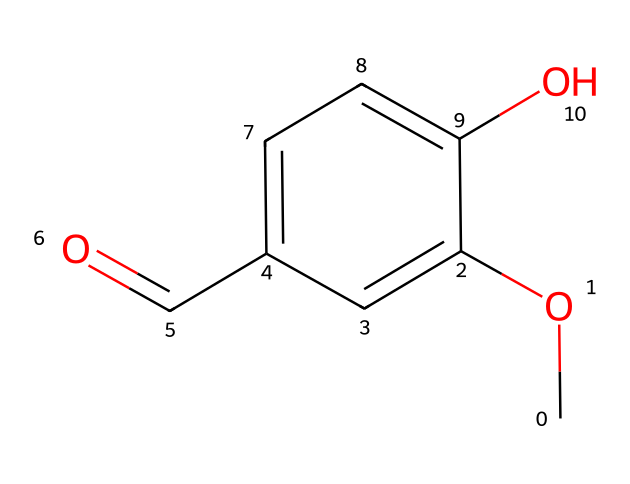What is the molecular formula of vanillin? The molecular formula can be derived from the SMILES representation by counting the atoms. In the representation, there is one carbonyl group (C=O), six carbons in the aromatic ring, two oxygen atoms, and six hydrogen atoms. Thus, the molecular formula is C8H8O3.
Answer: C8H8O3 How many carbon atoms are present in vanillin? By examining the SMILES representation, we can count the carbon atoms. There are a total of eight carbon atoms in the structure: one in the carbonyl group and the remaining seven in the aromatic ring.
Answer: 8 What functional groups are present in vanillin? From the SMILES structure, we can identify the functional groups. The key identifiable groups are an aldehyde (C=O) and a methoxy group (O-CH3) attached to the aromatic ring. Therefore, the functional groups present are aldehyde and ether.
Answer: aldehyde and ether Is vanillin an aromatic compound? An aromatic compound typically has a cyclic structure with delocalized pi electrons. In the SMILES representation, vanillin has a benzene ring which confirms it has a cyclic structure with delocalized electrons. Thus, it qualifies as an aromatic compound.
Answer: yes Why does vanillin have a characteristic sweet smell? The characteristic sweet smell comes from the specific arrangement of atoms in the molecule. The aromatic ring and functional groups contribute to the sensory properties by interacting with the olfactory receptors. This indicates that the molecular structure defines its sensory characteristics.
Answer: arrangement of atoms What indicates that vanillin is an aldehyde? In the SMILES representation, the presence of the carbonyl group (C=O) at the end of a carbon chain (attached to a carbon in a ring) signifies it is an aldehyde, which specifically has the structure R-CHO.
Answer: carbonyl group 